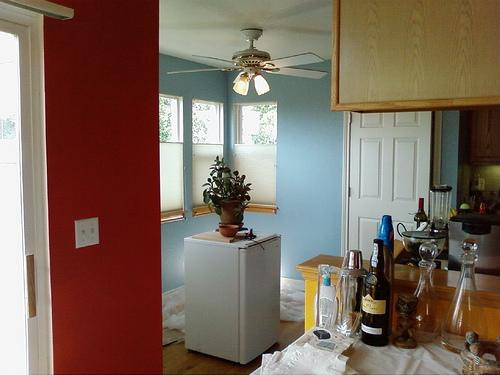What is sitting on the mini fridge in the center of the room?

Choices:
A) potted plant
B) small child
C) adult male
D) hammer potted plant 